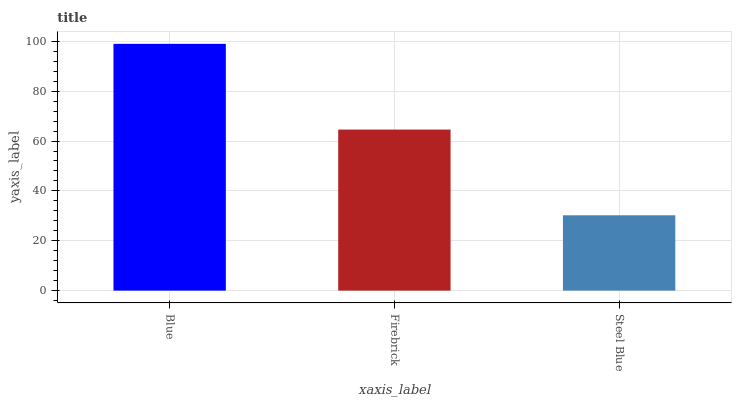Is Steel Blue the minimum?
Answer yes or no. Yes. Is Blue the maximum?
Answer yes or no. Yes. Is Firebrick the minimum?
Answer yes or no. No. Is Firebrick the maximum?
Answer yes or no. No. Is Blue greater than Firebrick?
Answer yes or no. Yes. Is Firebrick less than Blue?
Answer yes or no. Yes. Is Firebrick greater than Blue?
Answer yes or no. No. Is Blue less than Firebrick?
Answer yes or no. No. Is Firebrick the high median?
Answer yes or no. Yes. Is Firebrick the low median?
Answer yes or no. Yes. Is Blue the high median?
Answer yes or no. No. Is Steel Blue the low median?
Answer yes or no. No. 